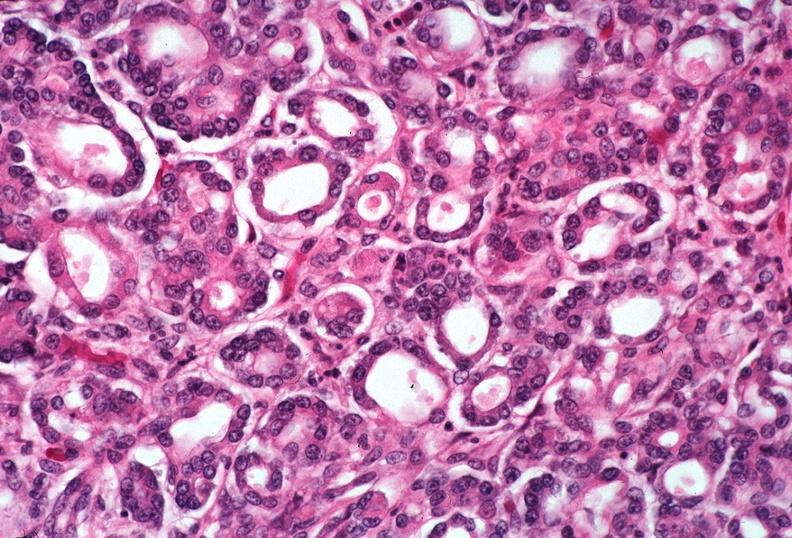what does this image show?
Answer the question using a single word or phrase. Pancreas 